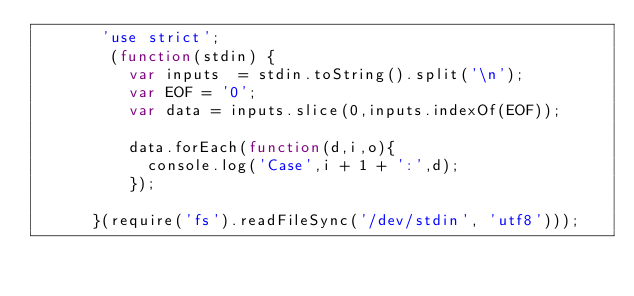<code> <loc_0><loc_0><loc_500><loc_500><_JavaScript_>       'use strict';
        (function(stdin) {
          var inputs  = stdin.toString().split('\n');
          var EOF = '0';
          var data = inputs.slice(0,inputs.indexOf(EOF));
          
          data.forEach(function(d,i,o){
            console.log('Case',i + 1 + ':',d);
          });

      }(require('fs').readFileSync('/dev/stdin', 'utf8')));</code> 